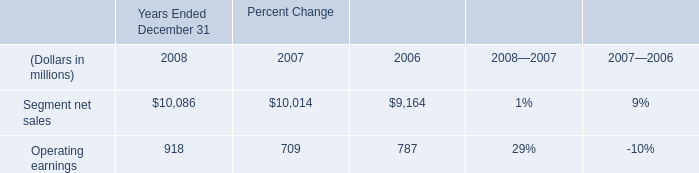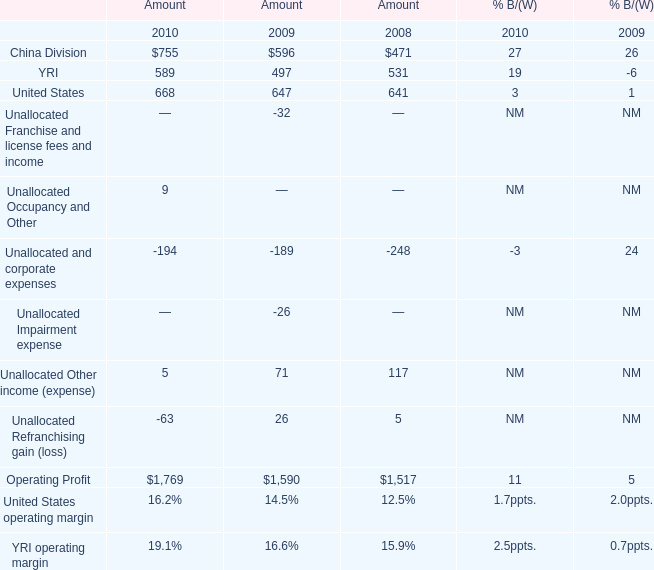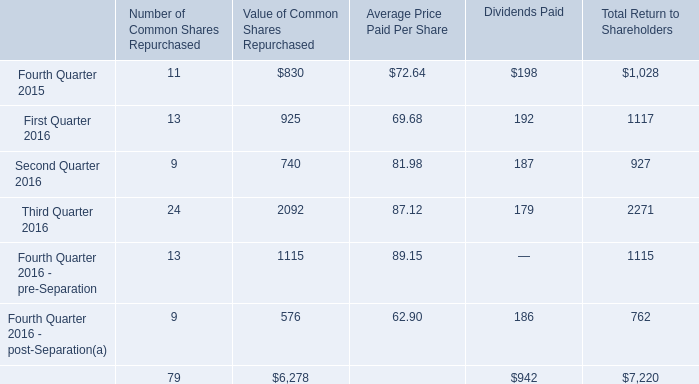What is the average amount of Operating Profit of Amount 2008, and Third Quarter 2016 of Value of Common Shares Repurchased ? 
Computations: ((1517.0 + 2092.0) / 2)
Answer: 1804.5. 